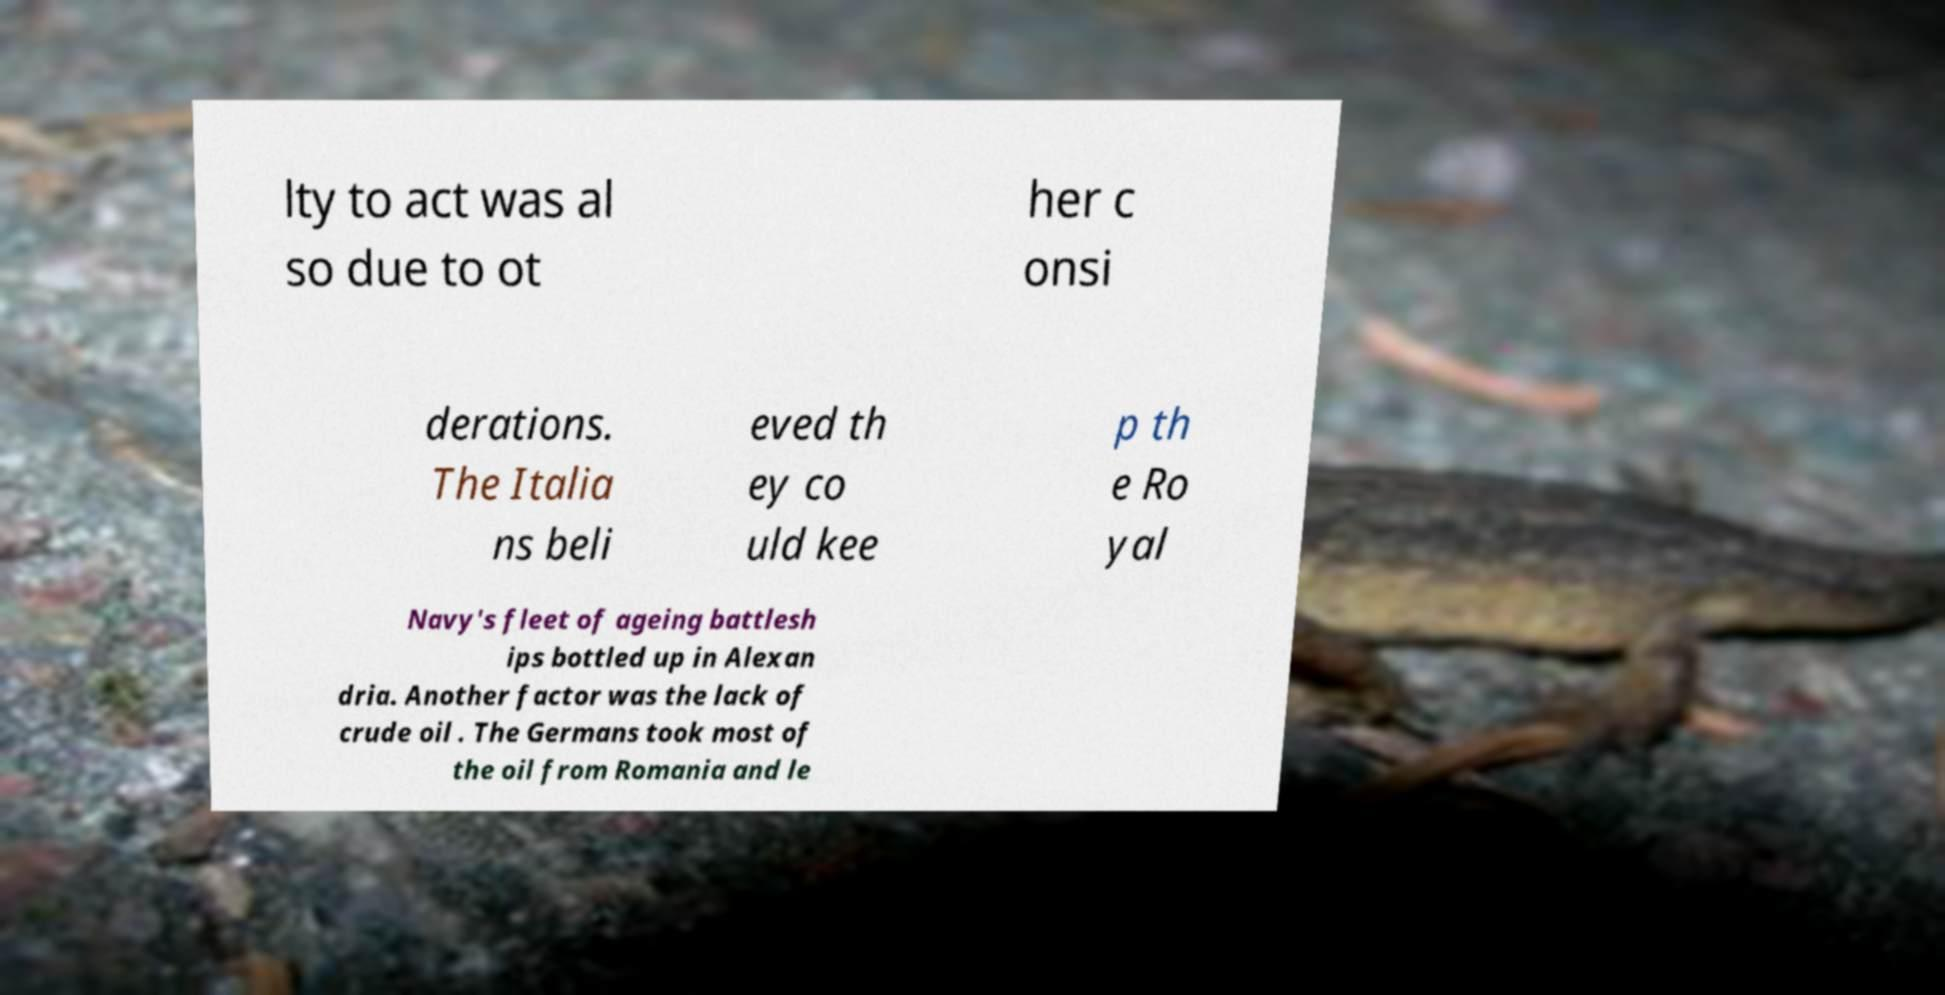Could you assist in decoding the text presented in this image and type it out clearly? lty to act was al so due to ot her c onsi derations. The Italia ns beli eved th ey co uld kee p th e Ro yal Navy's fleet of ageing battlesh ips bottled up in Alexan dria. Another factor was the lack of crude oil . The Germans took most of the oil from Romania and le 